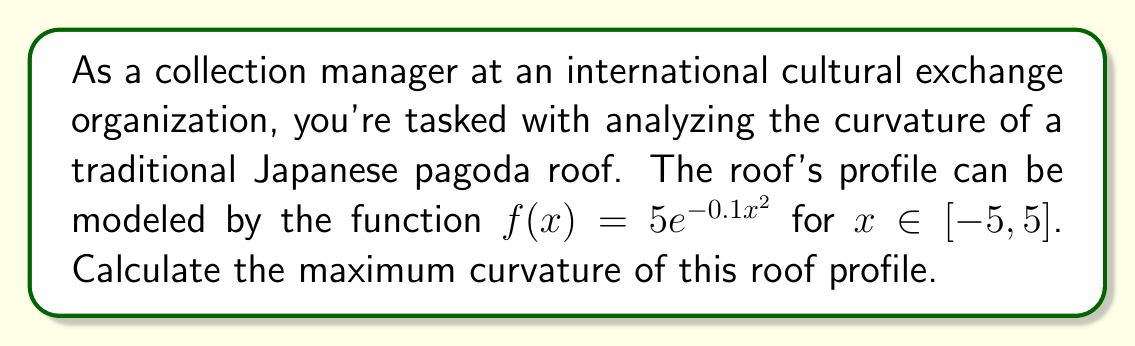Solve this math problem. To find the maximum curvature of the roof profile, we'll follow these steps:

1) The curvature κ of a function $y = f(x)$ is given by:

   $$κ = \frac{|f''(x)|}{(1 + (f'(x))^2)^{3/2}}$$

2) First, let's calculate $f'(x)$ and $f''(x)$:

   $f'(x) = 5e^{-0.1x^2} \cdot (-0.2x) = -x e^{-0.1x^2}$
   
   $f''(x) = -e^{-0.1x^2} + 0.2x^2 e^{-0.1x^2} = e^{-0.1x^2}(0.2x^2 - 1)$

3) Substituting these into the curvature formula:

   $$κ = \frac{|e^{-0.1x^2}(0.2x^2 - 1)|}{(1 + (xe^{-0.1x^2})^2)^{3/2}}$$

4) To find the maximum curvature, we need to find where $\frac{dκ}{dx} = 0$. However, this leads to a complex equation that's difficult to solve analytically.

5) Instead, we can observe that the function is symmetric around $x = 0$, and the curvature will be maximum at the point where the roof curve is sharpest, which is at the peak $(x = 0)$.

6) Evaluating the curvature at $x = 0$:

   $$κ(0) = \frac{|e^{0}(-1)|}{(1 + 0^2)^{3/2}} = 1$$

Therefore, the maximum curvature of the roof profile is 1.
Answer: 1 